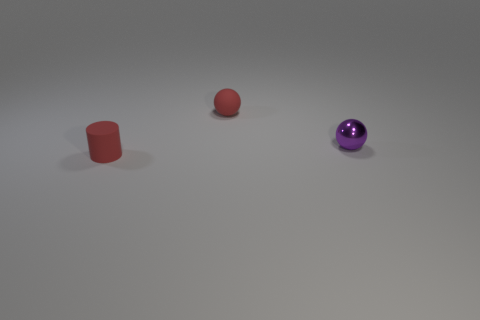Can you describe the surface the objects are on? The objects are resting on a flat, smooth surface with a slightly reflective quality that suggests it's polished. The gentle gradient on the surface, subtly darker near the objects and lighter further away, gives an impression of a studio setting designed to highlight the shapes and features of the objects. It's a neutral setting that ensures the objects are the focal points of the composition. 